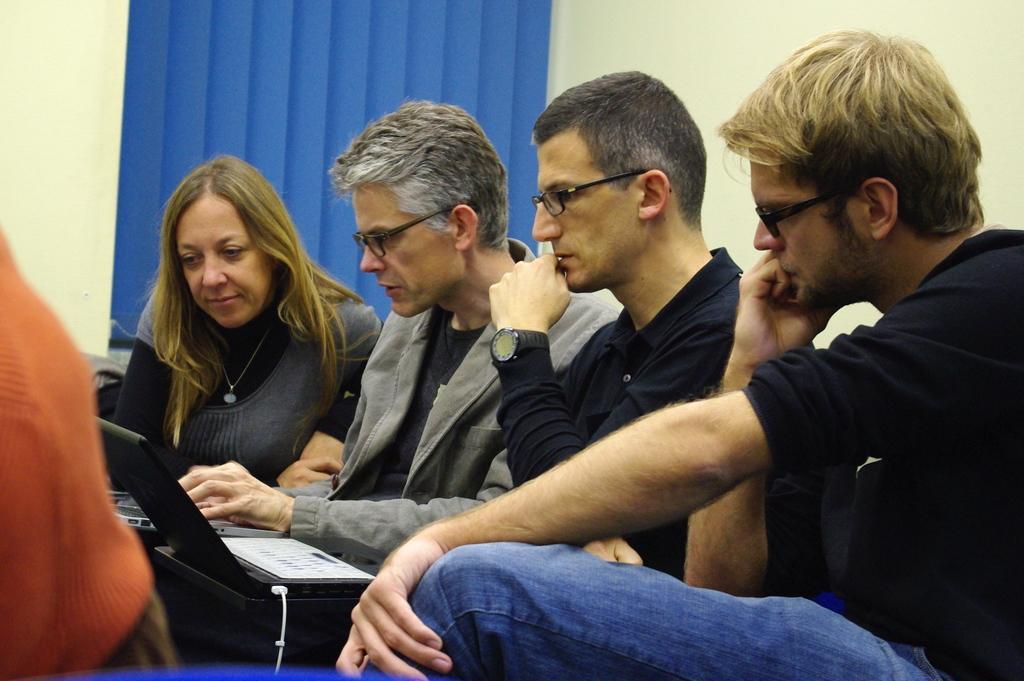In one or two sentences, can you explain what this image depicts? In the image there are four people sitting and discussing something by operating laptops, behind them there is a wall and on the left side there is a window. 